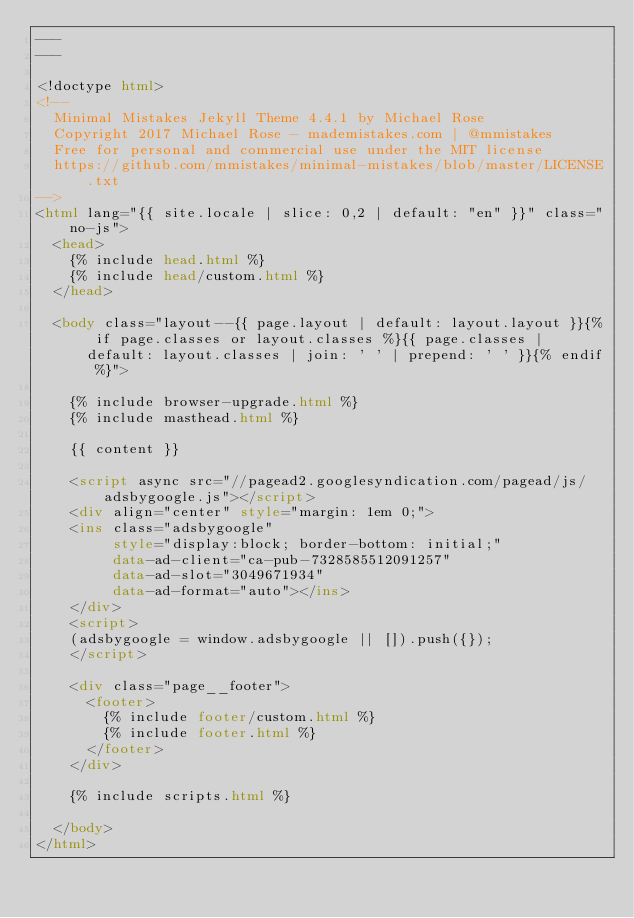Convert code to text. <code><loc_0><loc_0><loc_500><loc_500><_HTML_>---
---

<!doctype html>
<!--
  Minimal Mistakes Jekyll Theme 4.4.1 by Michael Rose
  Copyright 2017 Michael Rose - mademistakes.com | @mmistakes
  Free for personal and commercial use under the MIT license
  https://github.com/mmistakes/minimal-mistakes/blob/master/LICENSE.txt
-->
<html lang="{{ site.locale | slice: 0,2 | default: "en" }}" class="no-js">
  <head>
    {% include head.html %}
    {% include head/custom.html %}
  </head>

  <body class="layout--{{ page.layout | default: layout.layout }}{% if page.classes or layout.classes %}{{ page.classes | default: layout.classes | join: ' ' | prepend: ' ' }}{% endif %}">

    {% include browser-upgrade.html %}
    {% include masthead.html %}

    {{ content }}

    <script async src="//pagead2.googlesyndication.com/pagead/js/adsbygoogle.js"></script>
    <div align="center" style="margin: 1em 0;">
    <ins class="adsbygoogle"
         style="display:block; border-bottom: initial;"
         data-ad-client="ca-pub-7328585512091257"
         data-ad-slot="3049671934"
         data-ad-format="auto"></ins>
    </div>
    <script>
    (adsbygoogle = window.adsbygoogle || []).push({});
    </script>

    <div class="page__footer">
      <footer>
        {% include footer/custom.html %}
        {% include footer.html %}
      </footer>
    </div>

    {% include scripts.html %}

  </body>
</html>
</code> 